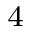Convert formula to latex. <formula><loc_0><loc_0><loc_500><loc_500>^ { 4 }</formula> 